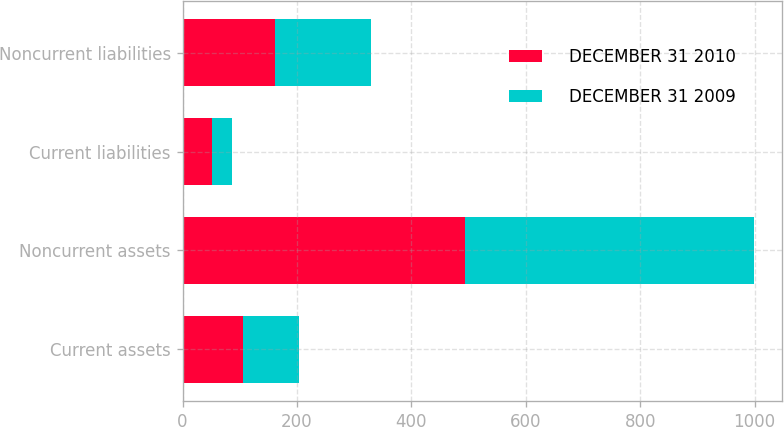Convert chart to OTSL. <chart><loc_0><loc_0><loc_500><loc_500><stacked_bar_chart><ecel><fcel>Current assets<fcel>Noncurrent assets<fcel>Current liabilities<fcel>Noncurrent liabilities<nl><fcel>DECEMBER 31 2010<fcel>105<fcel>494<fcel>52<fcel>161<nl><fcel>DECEMBER 31 2009<fcel>99<fcel>504<fcel>35<fcel>168<nl></chart> 